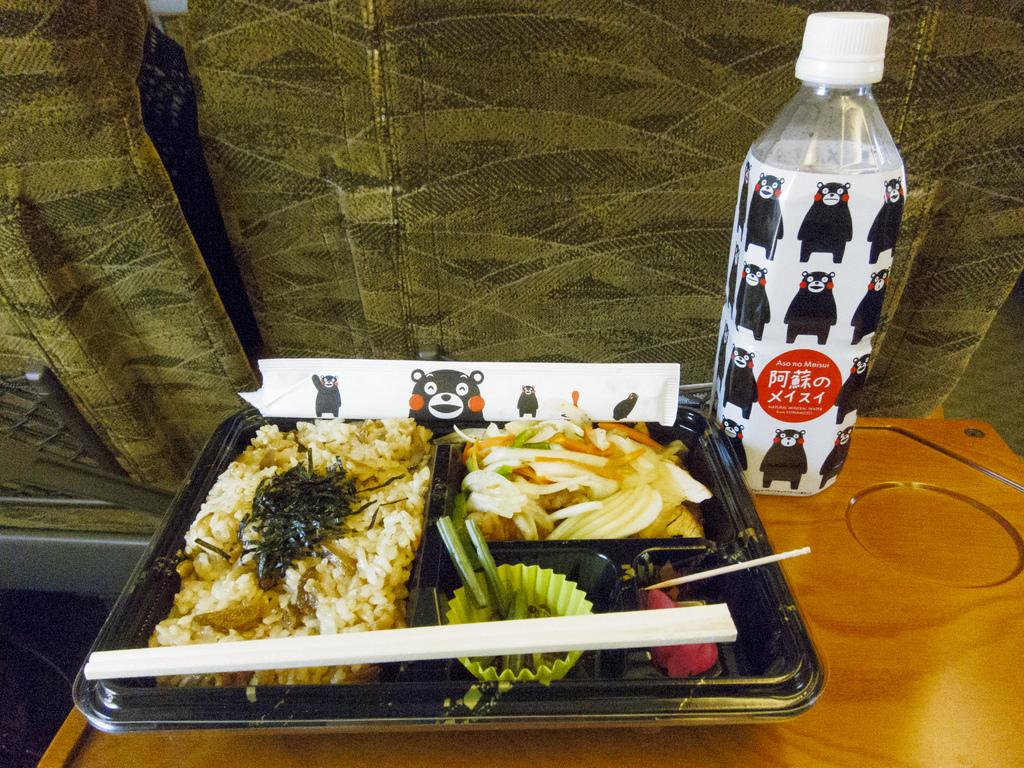Provide a one-sentence caption for the provided image. A tray filled with various types of food and a water bottle next to it. 